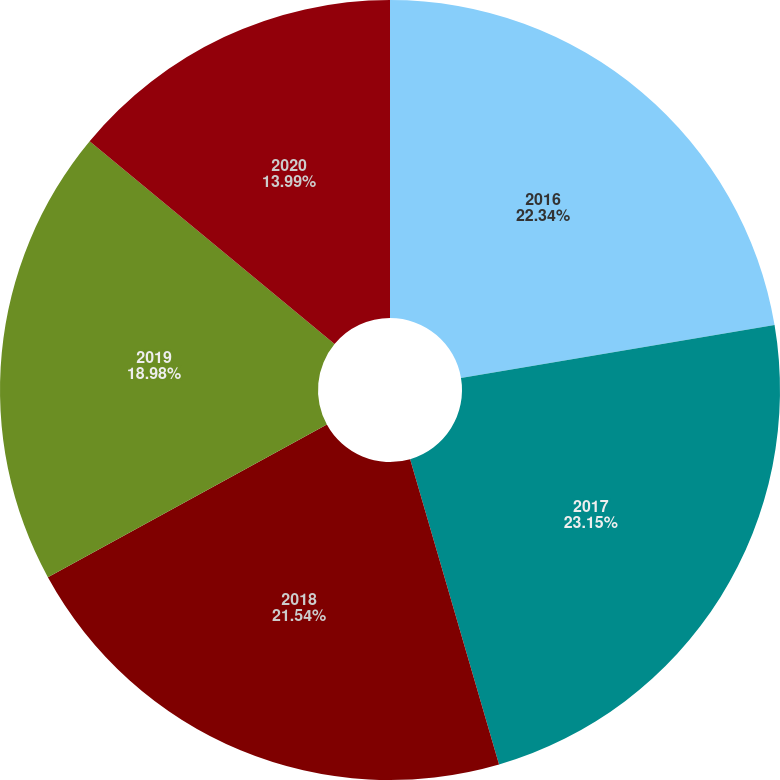Convert chart to OTSL. <chart><loc_0><loc_0><loc_500><loc_500><pie_chart><fcel>2016<fcel>2017<fcel>2018<fcel>2019<fcel>2020<nl><fcel>22.34%<fcel>23.15%<fcel>21.54%<fcel>18.98%<fcel>13.99%<nl></chart> 